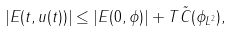Convert formula to latex. <formula><loc_0><loc_0><loc_500><loc_500>| E ( t , u ( t ) ) | \leq | E ( 0 , \phi ) | + T \tilde { C } ( \| \phi \| _ { L ^ { 2 } } ) ,</formula> 